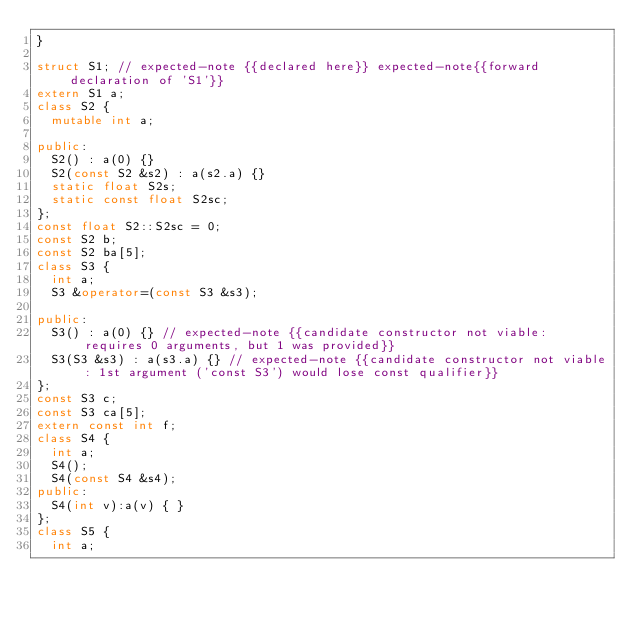Convert code to text. <code><loc_0><loc_0><loc_500><loc_500><_C++_>}

struct S1; // expected-note {{declared here}} expected-note{{forward declaration of 'S1'}}
extern S1 a;
class S2 {
  mutable int a;
  
public:
  S2() : a(0) {}
  S2(const S2 &s2) : a(s2.a) {}
  static float S2s;
  static const float S2sc;
};
const float S2::S2sc = 0;
const S2 b;
const S2 ba[5];
class S3 {
  int a;
  S3 &operator=(const S3 &s3);
  
public:
  S3() : a(0) {} // expected-note {{candidate constructor not viable: requires 0 arguments, but 1 was provided}}
  S3(S3 &s3) : a(s3.a) {} // expected-note {{candidate constructor not viable: 1st argument ('const S3') would lose const qualifier}}
};
const S3 c;
const S3 ca[5];
extern const int f;
class S4 {
  int a;
  S4();
  S4(const S4 &s4);
public:
  S4(int v):a(v) { }
};
class S5 {
  int a;</code> 